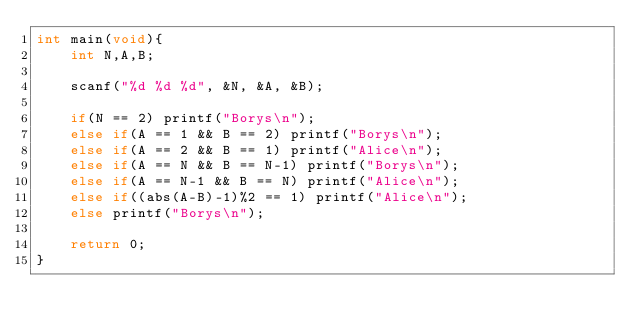Convert code to text. <code><loc_0><loc_0><loc_500><loc_500><_C_>int main(void){
	int N,A,B;

	scanf("%d %d %d", &N, &A, &B);

	if(N == 2) printf("Borys\n");
	else if(A == 1 && B == 2) printf("Borys\n");
	else if(A == 2 && B == 1) printf("Alice\n");
	else if(A == N && B == N-1) printf("Borys\n");
	else if(A == N-1 && B == N) printf("Alice\n");
	else if((abs(A-B)-1)%2 == 1) printf("Alice\n");
	else printf("Borys\n");

	return 0;
}</code> 